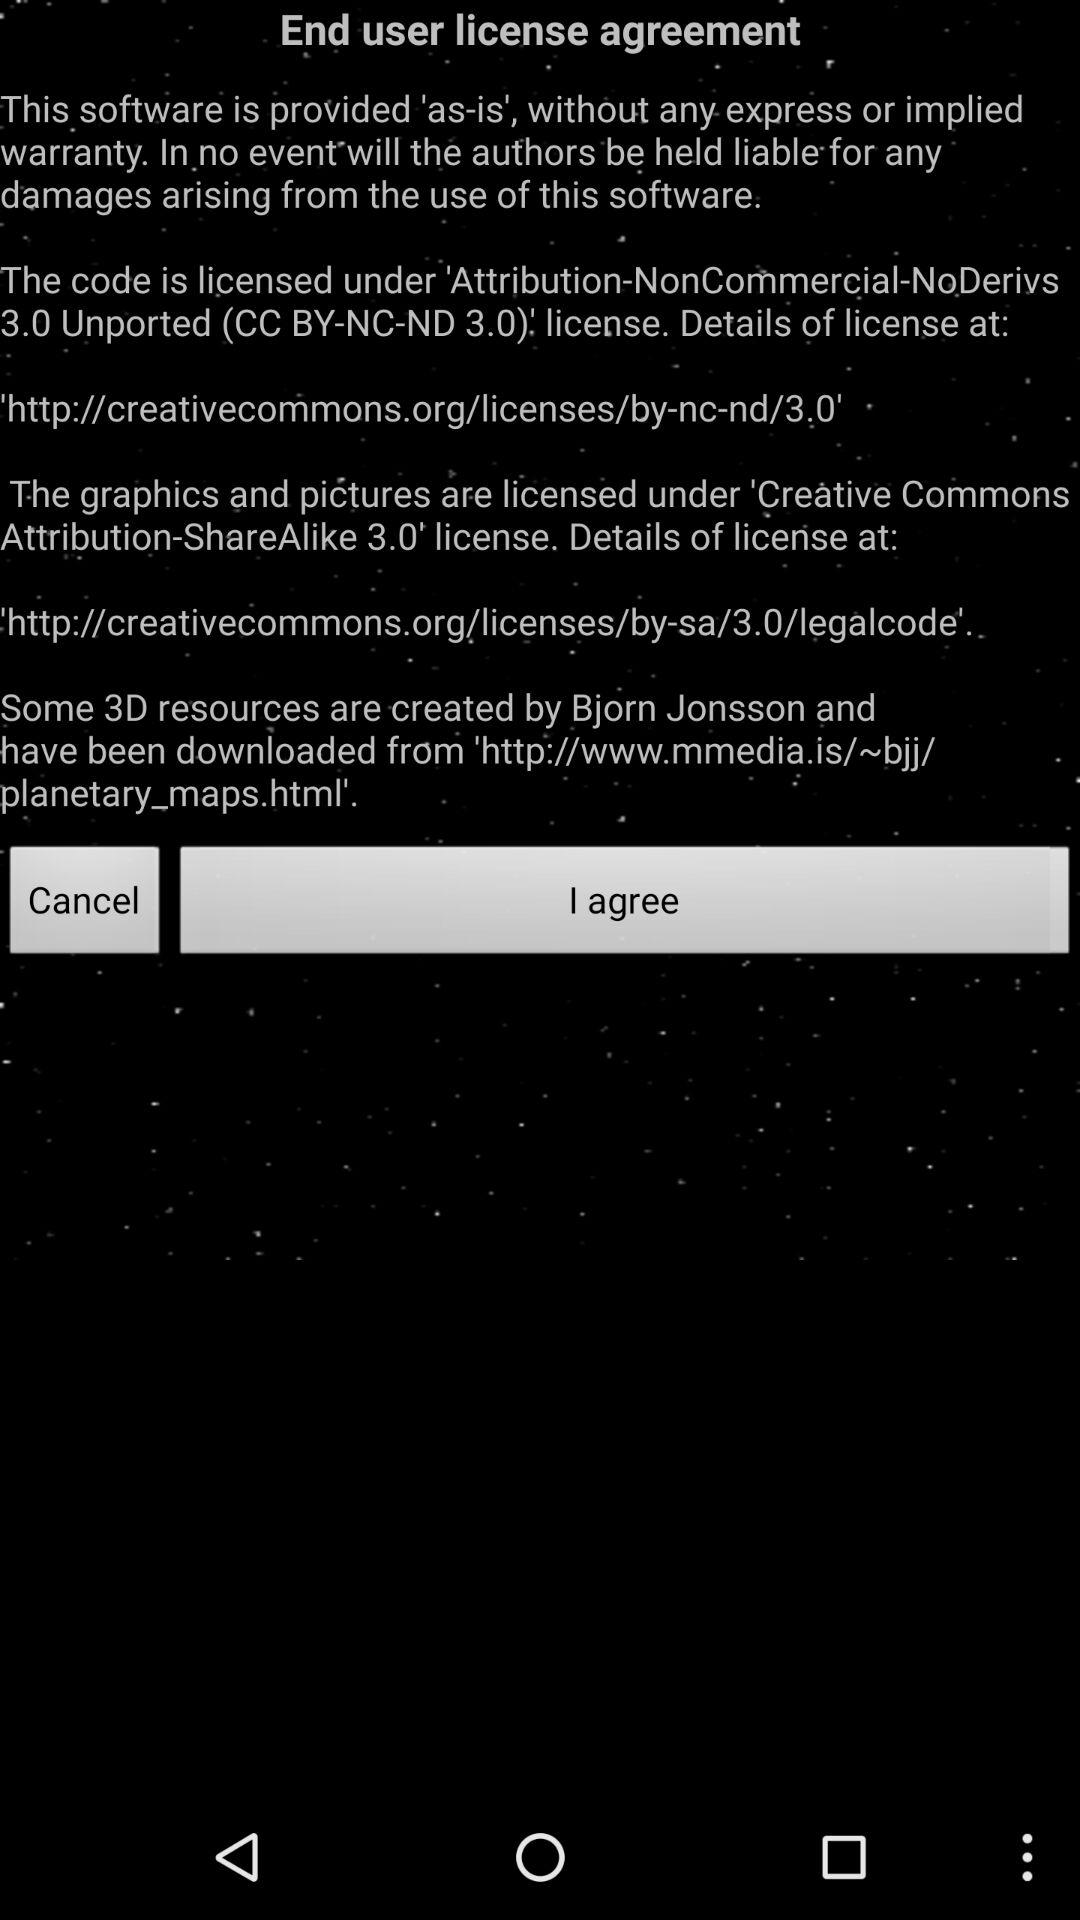How many links to license details are there in the end user license agreement?
Answer the question using a single word or phrase. 2 